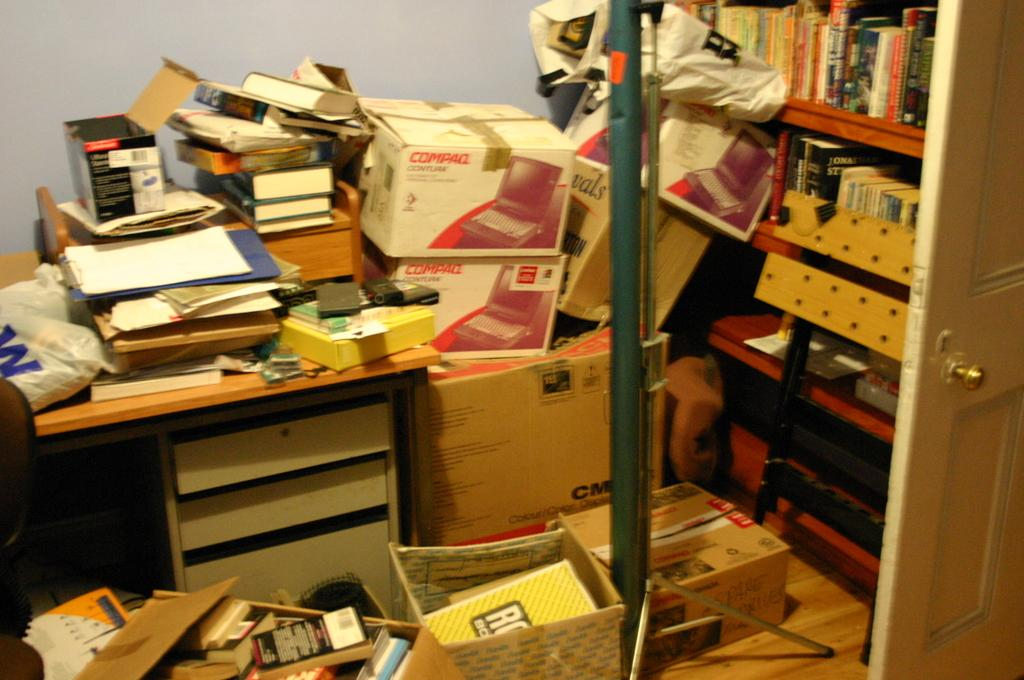<image>
Offer a succinct explanation of the picture presented. A crowded office with two compaq branded boxes stacked on top of each other. 